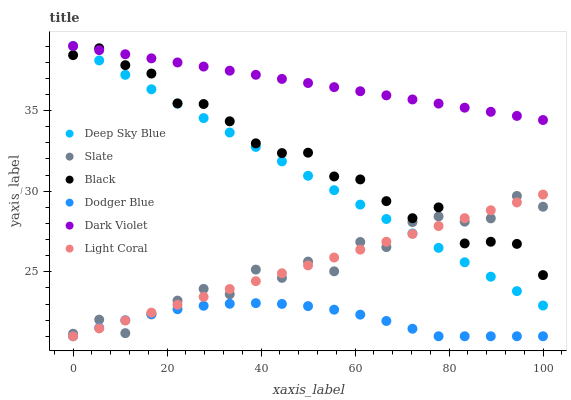Does Dodger Blue have the minimum area under the curve?
Answer yes or no. Yes. Does Dark Violet have the maximum area under the curve?
Answer yes or no. Yes. Does Light Coral have the minimum area under the curve?
Answer yes or no. No. Does Light Coral have the maximum area under the curve?
Answer yes or no. No. Is Dark Violet the smoothest?
Answer yes or no. Yes. Is Slate the roughest?
Answer yes or no. Yes. Is Light Coral the smoothest?
Answer yes or no. No. Is Light Coral the roughest?
Answer yes or no. No. Does Light Coral have the lowest value?
Answer yes or no. Yes. Does Dark Violet have the lowest value?
Answer yes or no. No. Does Deep Sky Blue have the highest value?
Answer yes or no. Yes. Does Light Coral have the highest value?
Answer yes or no. No. Is Slate less than Dark Violet?
Answer yes or no. Yes. Is Black greater than Dodger Blue?
Answer yes or no. Yes. Does Dark Violet intersect Deep Sky Blue?
Answer yes or no. Yes. Is Dark Violet less than Deep Sky Blue?
Answer yes or no. No. Is Dark Violet greater than Deep Sky Blue?
Answer yes or no. No. Does Slate intersect Dark Violet?
Answer yes or no. No. 